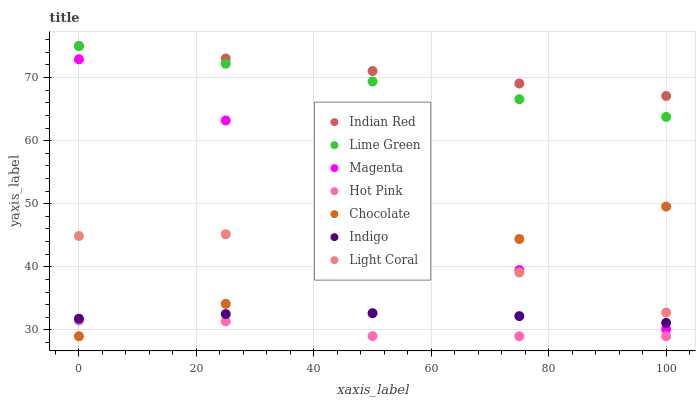Does Hot Pink have the minimum area under the curve?
Answer yes or no. Yes. Does Indian Red have the maximum area under the curve?
Answer yes or no. Yes. Does Chocolate have the minimum area under the curve?
Answer yes or no. No. Does Chocolate have the maximum area under the curve?
Answer yes or no. No. Is Lime Green the smoothest?
Answer yes or no. Yes. Is Magenta the roughest?
Answer yes or no. Yes. Is Hot Pink the smoothest?
Answer yes or no. No. Is Hot Pink the roughest?
Answer yes or no. No. Does Hot Pink have the lowest value?
Answer yes or no. Yes. Does Light Coral have the lowest value?
Answer yes or no. No. Does Lime Green have the highest value?
Answer yes or no. Yes. Does Chocolate have the highest value?
Answer yes or no. No. Is Indigo less than Light Coral?
Answer yes or no. Yes. Is Lime Green greater than Indigo?
Answer yes or no. Yes. Does Magenta intersect Indigo?
Answer yes or no. Yes. Is Magenta less than Indigo?
Answer yes or no. No. Is Magenta greater than Indigo?
Answer yes or no. No. Does Indigo intersect Light Coral?
Answer yes or no. No. 